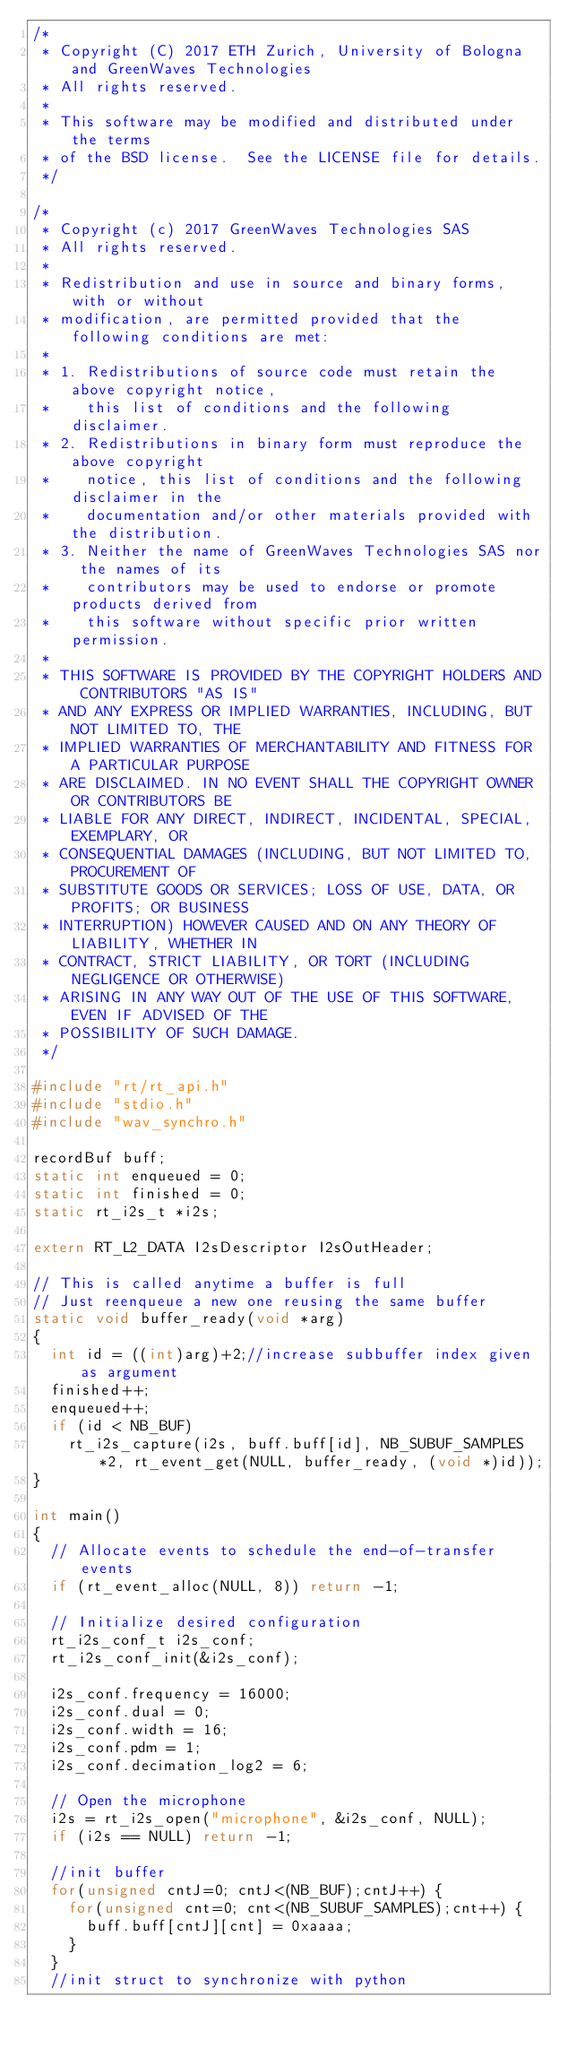<code> <loc_0><loc_0><loc_500><loc_500><_C_>/*
 * Copyright (C) 2017 ETH Zurich, University of Bologna and GreenWaves Technologies
 * All rights reserved.
 *
 * This software may be modified and distributed under the terms
 * of the BSD license.  See the LICENSE file for details.
 */

/*
 * Copyright (c) 2017 GreenWaves Technologies SAS
 * All rights reserved.
 *
 * Redistribution and use in source and binary forms, with or without
 * modification, are permitted provided that the following conditions are met:
 *
 * 1. Redistributions of source code must retain the above copyright notice,
 *    this list of conditions and the following disclaimer.
 * 2. Redistributions in binary form must reproduce the above copyright
 *    notice, this list of conditions and the following disclaimer in the
 *    documentation and/or other materials provided with the distribution.
 * 3. Neither the name of GreenWaves Technologies SAS nor the names of its
 *    contributors may be used to endorse or promote products derived from
 *    this software without specific prior written permission.
 *
 * THIS SOFTWARE IS PROVIDED BY THE COPYRIGHT HOLDERS AND CONTRIBUTORS "AS IS"
 * AND ANY EXPRESS OR IMPLIED WARRANTIES, INCLUDING, BUT NOT LIMITED TO, THE
 * IMPLIED WARRANTIES OF MERCHANTABILITY AND FITNESS FOR A PARTICULAR PURPOSE
 * ARE DISCLAIMED. IN NO EVENT SHALL THE COPYRIGHT OWNER OR CONTRIBUTORS BE
 * LIABLE FOR ANY DIRECT, INDIRECT, INCIDENTAL, SPECIAL, EXEMPLARY, OR
 * CONSEQUENTIAL DAMAGES (INCLUDING, BUT NOT LIMITED TO, PROCUREMENT OF
 * SUBSTITUTE GOODS OR SERVICES; LOSS OF USE, DATA, OR PROFITS; OR BUSINESS
 * INTERRUPTION) HOWEVER CAUSED AND ON ANY THEORY OF LIABILITY, WHETHER IN
 * CONTRACT, STRICT LIABILITY, OR TORT (INCLUDING NEGLIGENCE OR OTHERWISE)
 * ARISING IN ANY WAY OUT OF THE USE OF THIS SOFTWARE, EVEN IF ADVISED OF THE
 * POSSIBILITY OF SUCH DAMAGE.
 */

#include "rt/rt_api.h"
#include "stdio.h"
#include "wav_synchro.h"

recordBuf buff;
static int enqueued = 0;
static int finished = 0;
static rt_i2s_t *i2s;

extern RT_L2_DATA I2sDescriptor I2sOutHeader;

// This is called anytime a buffer is full
// Just reenqueue a new one reusing the same buffer
static void buffer_ready(void *arg)
{
  int id = ((int)arg)+2;//increase subbuffer index given as argument
  finished++;
  enqueued++;
  if (id < NB_BUF)
    rt_i2s_capture(i2s, buff.buff[id], NB_SUBUF_SAMPLES*2, rt_event_get(NULL, buffer_ready, (void *)id));
}

int main()
{
  // Allocate events to schedule the end-of-transfer events
  if (rt_event_alloc(NULL, 8)) return -1;

  // Initialize desired configuration
  rt_i2s_conf_t i2s_conf;
  rt_i2s_conf_init(&i2s_conf);

  i2s_conf.frequency = 16000;
  i2s_conf.dual = 0;
  i2s_conf.width = 16;
  i2s_conf.pdm = 1;
  i2s_conf.decimation_log2 = 6;

  // Open the microphone
  i2s = rt_i2s_open("microphone", &i2s_conf, NULL);
  if (i2s == NULL) return -1;

  //init buffer
  for(unsigned cntJ=0; cntJ<(NB_BUF);cntJ++) {
    for(unsigned cnt=0; cnt<(NB_SUBUF_SAMPLES);cnt++) {
      buff.buff[cntJ][cnt] = 0xaaaa;
    }
  }
  //init struct to synchronize with python</code> 